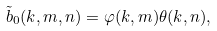<formula> <loc_0><loc_0><loc_500><loc_500>\tilde { b } _ { 0 } ( k , m , n ) = \varphi ( k , m ) \theta ( k , n ) ,</formula> 